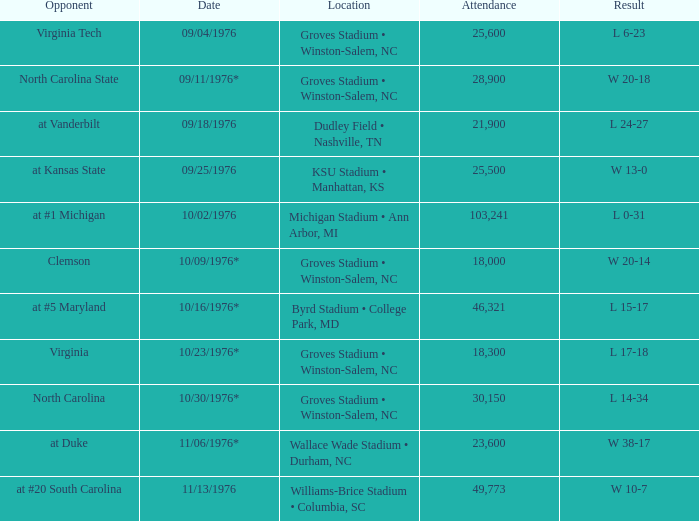What was the date of the game against North Carolina? 10/30/1976*. Write the full table. {'header': ['Opponent', 'Date', 'Location', 'Attendance', 'Result'], 'rows': [['Virginia Tech', '09/04/1976', 'Groves Stadium • Winston-Salem, NC', '25,600', 'L 6-23'], ['North Carolina State', '09/11/1976*', 'Groves Stadium • Winston-Salem, NC', '28,900', 'W 20-18'], ['at Vanderbilt', '09/18/1976', 'Dudley Field • Nashville, TN', '21,900', 'L 24-27'], ['at Kansas State', '09/25/1976', 'KSU Stadium • Manhattan, KS', '25,500', 'W 13-0'], ['at #1 Michigan', '10/02/1976', 'Michigan Stadium • Ann Arbor, MI', '103,241', 'L 0-31'], ['Clemson', '10/09/1976*', 'Groves Stadium • Winston-Salem, NC', '18,000', 'W 20-14'], ['at #5 Maryland', '10/16/1976*', 'Byrd Stadium • College Park, MD', '46,321', 'L 15-17'], ['Virginia', '10/23/1976*', 'Groves Stadium • Winston-Salem, NC', '18,300', 'L 17-18'], ['North Carolina', '10/30/1976*', 'Groves Stadium • Winston-Salem, NC', '30,150', 'L 14-34'], ['at Duke', '11/06/1976*', 'Wallace Wade Stadium • Durham, NC', '23,600', 'W 38-17'], ['at #20 South Carolina', '11/13/1976', 'Williams-Brice Stadium • Columbia, SC', '49,773', 'W 10-7']]} 